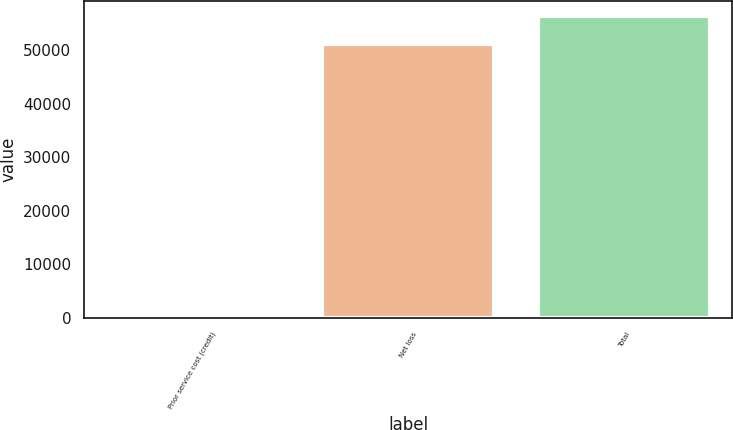Convert chart to OTSL. <chart><loc_0><loc_0><loc_500><loc_500><bar_chart><fcel>Prior service cost (credit)<fcel>Net loss<fcel>Total<nl><fcel>275<fcel>51240<fcel>56364<nl></chart> 